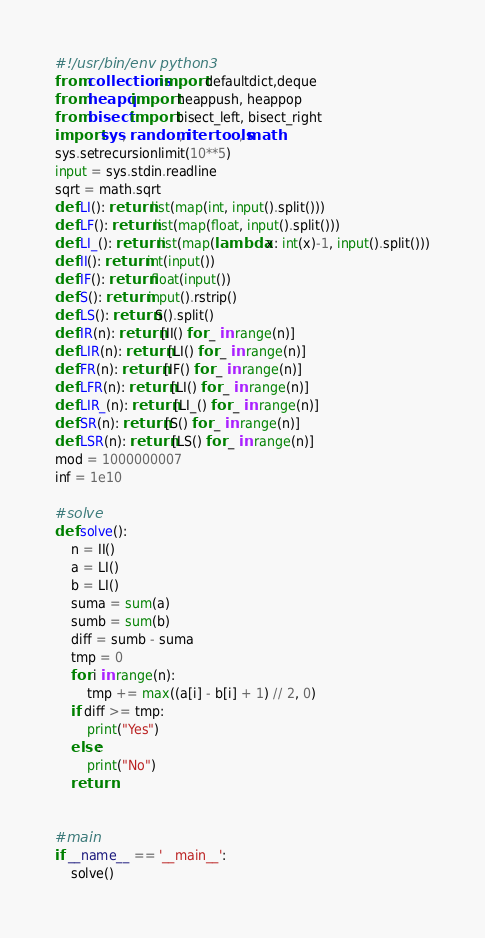<code> <loc_0><loc_0><loc_500><loc_500><_Python_>#!/usr/bin/env python3
from collections import defaultdict,deque
from heapq import heappush, heappop
from bisect import bisect_left, bisect_right
import sys, random, itertools, math
sys.setrecursionlimit(10**5)
input = sys.stdin.readline
sqrt = math.sqrt
def LI(): return list(map(int, input().split()))
def LF(): return list(map(float, input().split()))
def LI_(): return list(map(lambda x: int(x)-1, input().split()))
def II(): return int(input())
def IF(): return float(input())
def S(): return input().rstrip()
def LS(): return S().split()
def IR(n): return [II() for _ in range(n)]
def LIR(n): return [LI() for _ in range(n)]
def FR(n): return [IF() for _ in range(n)]
def LFR(n): return [LI() for _ in range(n)]
def LIR_(n): return [LI_() for _ in range(n)]
def SR(n): return [S() for _ in range(n)]
def LSR(n): return [LS() for _ in range(n)]
mod = 1000000007
inf = 1e10

#solve
def solve():
    n = II()
    a = LI()
    b = LI()
    suma = sum(a)
    sumb = sum(b)
    diff = sumb - suma
    tmp = 0
    for i in range(n):
        tmp += max((a[i] - b[i] + 1) // 2, 0)
    if diff >= tmp:
        print("Yes")
    else:
        print("No")
    return


#main
if __name__ == '__main__':
    solve()
</code> 